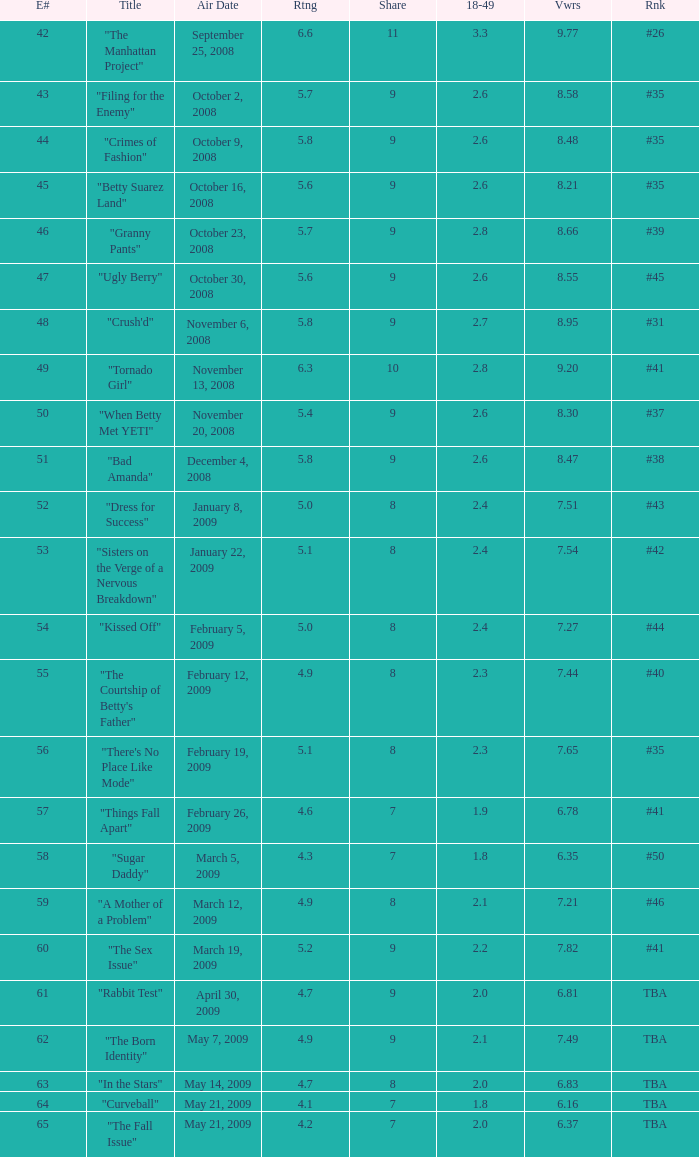What is the total number of Viewers when the rank is #40? 1.0. 